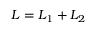<formula> <loc_0><loc_0><loc_500><loc_500>L = L _ { 1 } + L _ { 2 }</formula> 